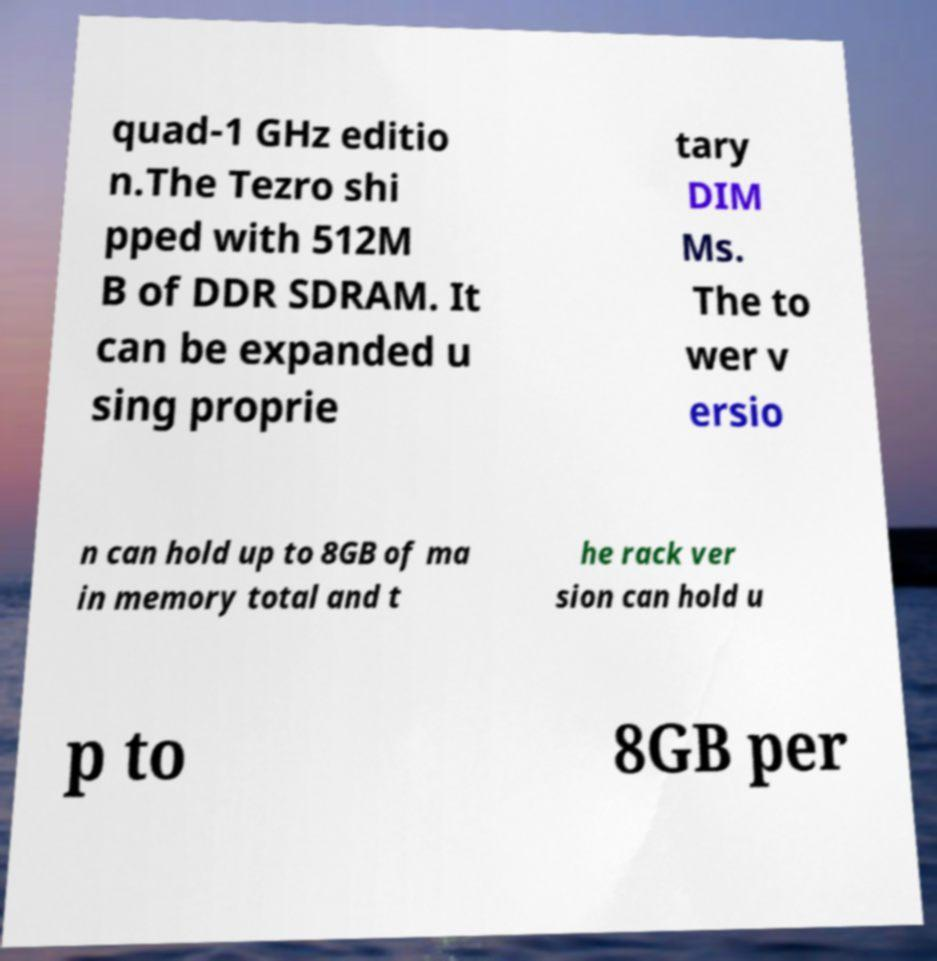I need the written content from this picture converted into text. Can you do that? quad-1 GHz editio n.The Tezro shi pped with 512M B of DDR SDRAM. It can be expanded u sing proprie tary DIM Ms. The to wer v ersio n can hold up to 8GB of ma in memory total and t he rack ver sion can hold u p to 8GB per 